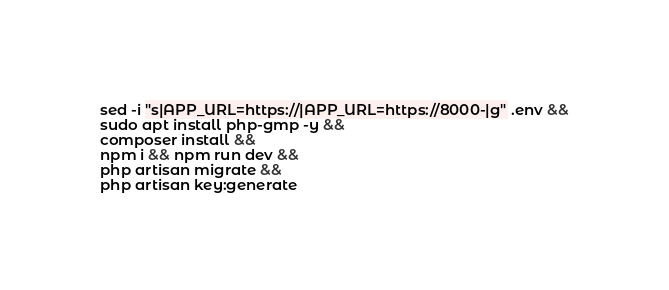Convert code to text. <code><loc_0><loc_0><loc_500><loc_500><_Bash_>sed -i "s|APP_URL=https://|APP_URL=https://8000-|g" .env &&
sudo apt install php-gmp -y &&
composer install &&
npm i && npm run dev &&
php artisan migrate &&
php artisan key:generate 

</code> 